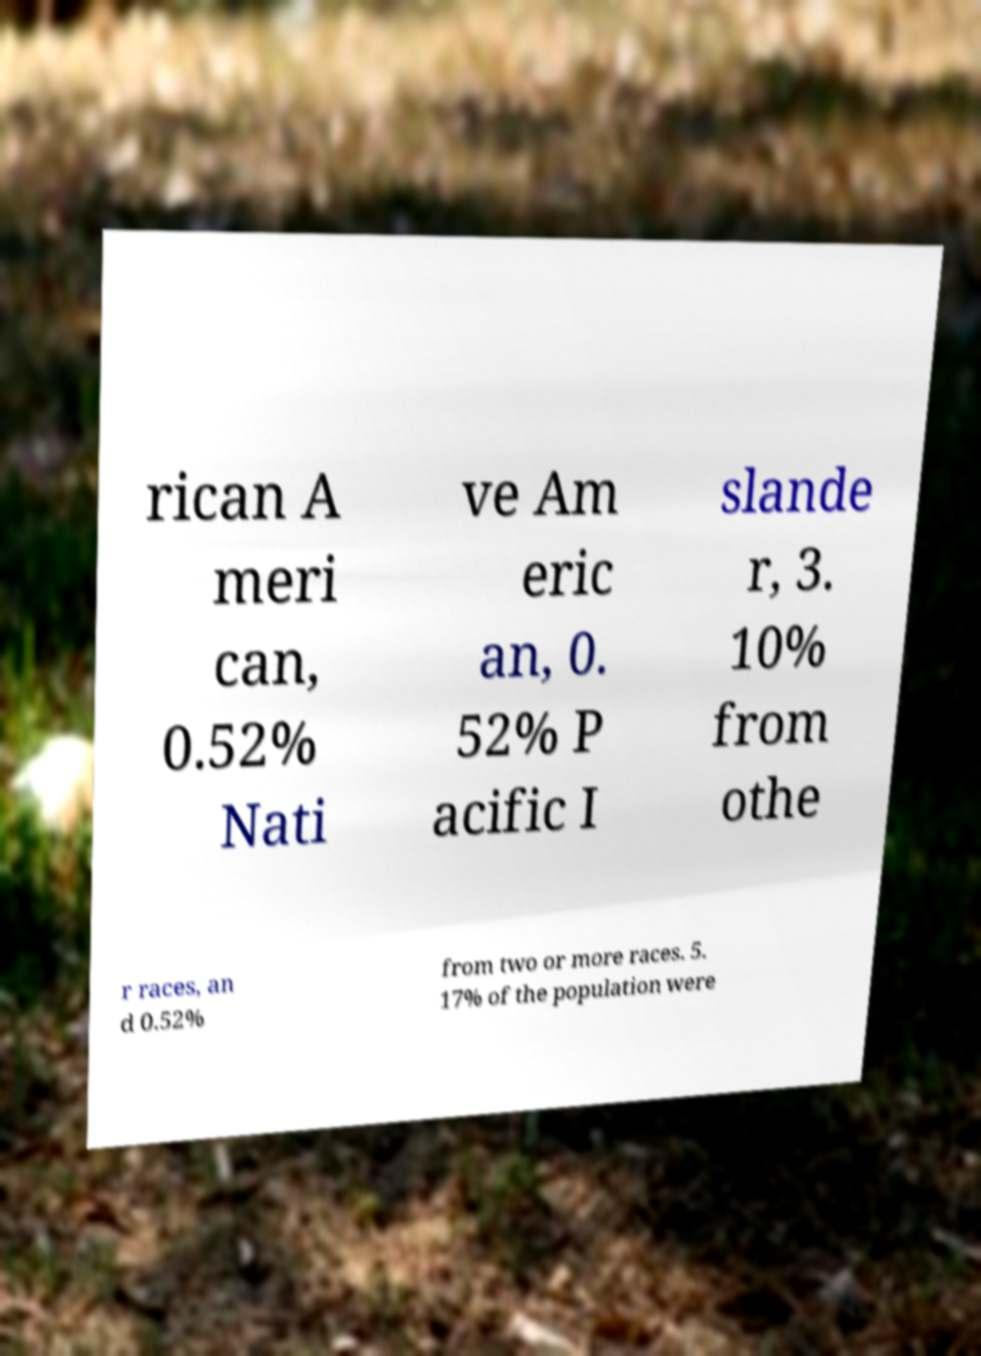Could you assist in decoding the text presented in this image and type it out clearly? rican A meri can, 0.52% Nati ve Am eric an, 0. 52% P acific I slande r, 3. 10% from othe r races, an d 0.52% from two or more races. 5. 17% of the population were 